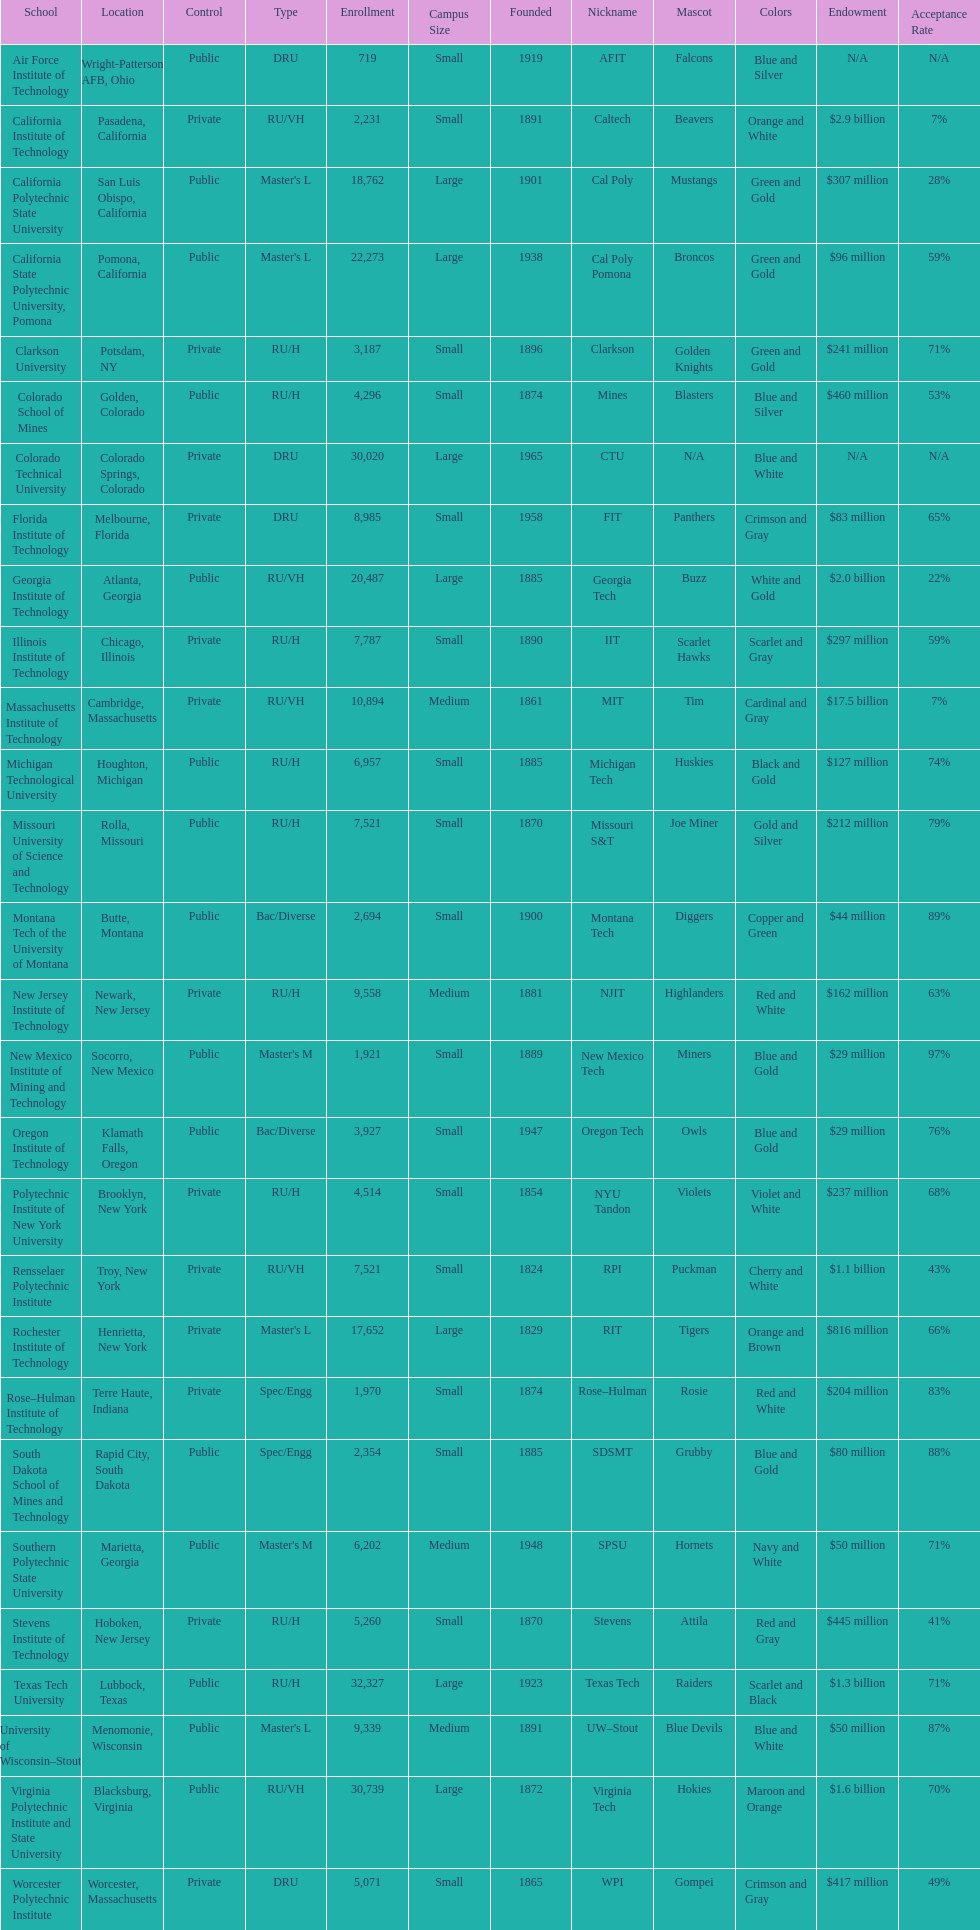Help me parse the entirety of this table. {'header': ['School', 'Location', 'Control', 'Type', 'Enrollment', 'Campus Size', 'Founded', 'Nickname', 'Mascot', 'Colors', 'Endowment', 'Acceptance Rate'], 'rows': [['Air Force Institute of Technology', 'Wright-Patterson AFB, Ohio', 'Public', 'DRU', '719', 'Small', '1919', 'AFIT', 'Falcons', 'Blue and Silver', 'N/A', 'N/A'], ['California Institute of Technology', 'Pasadena, California', 'Private', 'RU/VH', '2,231', 'Small', '1891', 'Caltech', 'Beavers', 'Orange and White', '$2.9 billion', '7%'], ['California Polytechnic State University', 'San Luis Obispo, California', 'Public', "Master's L", '18,762', 'Large', '1901', 'Cal Poly', 'Mustangs', 'Green and Gold', '$307 million', '28%'], ['California State Polytechnic University, Pomona', 'Pomona, California', 'Public', "Master's L", '22,273', 'Large', '1938', 'Cal Poly Pomona', 'Broncos', 'Green and Gold', '$96 million', '59%'], ['Clarkson University', 'Potsdam, NY', 'Private', 'RU/H', '3,187', 'Small', '1896', 'Clarkson', 'Golden Knights', 'Green and Gold', '$241 million', '71%'], ['Colorado School of Mines', 'Golden, Colorado', 'Public', 'RU/H', '4,296', 'Small', '1874', 'Mines', 'Blasters', 'Blue and Silver', '$460 million', '53%'], ['Colorado Technical University', 'Colorado Springs, Colorado', 'Private', 'DRU', '30,020', 'Large', '1965', 'CTU', 'N/A', 'Blue and White', 'N/A', 'N/A'], ['Florida Institute of Technology', 'Melbourne, Florida', 'Private', 'DRU', '8,985', 'Small', '1958', 'FIT', 'Panthers', 'Crimson and Gray', '$83 million', '65%'], ['Georgia Institute of Technology', 'Atlanta, Georgia', 'Public', 'RU/VH', '20,487', 'Large', '1885', 'Georgia Tech', 'Buzz', 'White and Gold', '$2.0 billion', '22%'], ['Illinois Institute of Technology', 'Chicago, Illinois', 'Private', 'RU/H', '7,787', 'Small', '1890', 'IIT', 'Scarlet Hawks', 'Scarlet and Gray', '$297 million', '59%'], ['Massachusetts Institute of Technology', 'Cambridge, Massachusetts', 'Private', 'RU/VH', '10,894', 'Medium', '1861', 'MIT', 'Tim', 'Cardinal and Gray', '$17.5 billion', '7%'], ['Michigan Technological University', 'Houghton, Michigan', 'Public', 'RU/H', '6,957', 'Small', '1885', 'Michigan Tech', 'Huskies', 'Black and Gold', '$127 million', '74%'], ['Missouri University of Science and Technology', 'Rolla, Missouri', 'Public', 'RU/H', '7,521', 'Small', '1870', 'Missouri S&T', 'Joe Miner', 'Gold and Silver', '$212 million', '79%'], ['Montana Tech of the University of Montana', 'Butte, Montana', 'Public', 'Bac/Diverse', '2,694', 'Small', '1900', 'Montana Tech', 'Diggers', 'Copper and Green', '$44 million', '89%'], ['New Jersey Institute of Technology', 'Newark, New Jersey', 'Private', 'RU/H', '9,558', 'Medium', '1881', 'NJIT', 'Highlanders', 'Red and White', '$162 million', '63%'], ['New Mexico Institute of Mining and Technology', 'Socorro, New Mexico', 'Public', "Master's M", '1,921', 'Small', '1889', 'New Mexico Tech', 'Miners', 'Blue and Gold', '$29 million', '97%'], ['Oregon Institute of Technology', 'Klamath Falls, Oregon', 'Public', 'Bac/Diverse', '3,927', 'Small', '1947', 'Oregon Tech', 'Owls', 'Blue and Gold', '$29 million', '76%'], ['Polytechnic Institute of New York University', 'Brooklyn, New York', 'Private', 'RU/H', '4,514', 'Small', '1854', 'NYU Tandon', 'Violets', 'Violet and White', '$237 million', '68%'], ['Rensselaer Polytechnic Institute', 'Troy, New York', 'Private', 'RU/VH', '7,521', 'Small', '1824', 'RPI', 'Puckman', 'Cherry and White', '$1.1 billion', '43%'], ['Rochester Institute of Technology', 'Henrietta, New York', 'Private', "Master's L", '17,652', 'Large', '1829', 'RIT', 'Tigers', 'Orange and Brown', '$816 million', '66%'], ['Rose–Hulman Institute of Technology', 'Terre Haute, Indiana', 'Private', 'Spec/Engg', '1,970', 'Small', '1874', 'Rose–Hulman', 'Rosie', 'Red and White', '$204 million', '83%'], ['South Dakota School of Mines and Technology', 'Rapid City, South Dakota', 'Public', 'Spec/Engg', '2,354', 'Small', '1885', 'SDSMT', 'Grubby', 'Blue and Gold', '$80 million', '88%'], ['Southern Polytechnic State University', 'Marietta, Georgia', 'Public', "Master's M", '6,202', 'Medium', '1948', 'SPSU', 'Hornets', 'Navy and White', '$50 million', '71%'], ['Stevens Institute of Technology', 'Hoboken, New Jersey', 'Private', 'RU/H', '5,260', 'Small', '1870', 'Stevens', 'Attila', 'Red and Gray', '$445 million', '41%'], ['Texas Tech University', 'Lubbock, Texas', 'Public', 'RU/H', '32,327', 'Large', '1923', 'Texas Tech', 'Raiders', 'Scarlet and Black', '$1.3 billion', '71%'], ['University of Wisconsin–Stout', 'Menomonie, Wisconsin', 'Public', "Master's L", '9,339', 'Medium', '1891', 'UW–Stout', 'Blue Devils', 'Blue and White', '$50 million', '87%'], ['Virginia Polytechnic Institute and State University', 'Blacksburg, Virginia', 'Public', 'RU/VH', '30,739', 'Large', '1872', 'Virginia Tech', 'Hokies', 'Maroon and Orange', '$1.6 billion', '70%'], ['Worcester Polytechnic Institute', 'Worcester, Massachusetts', 'Private', 'DRU', '5,071', 'Small', '1865', 'WPI', 'Gompei', 'Crimson and Gray', '$417 million', '49%']]} Which school had the largest enrollment? Texas Tech University. 